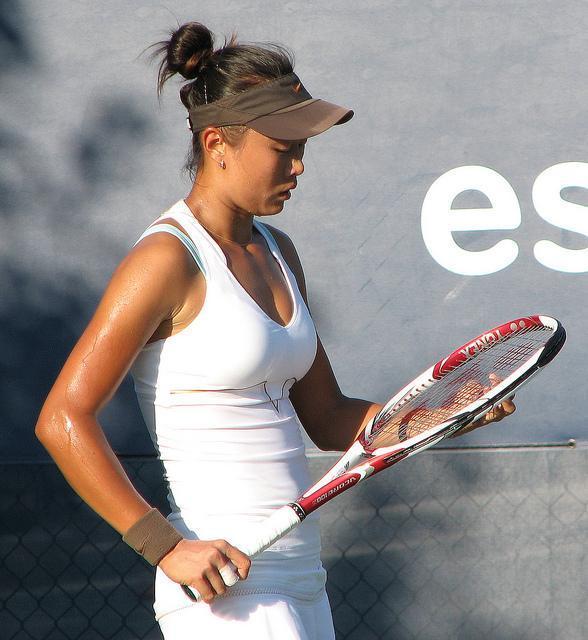How many kites are in the air?
Give a very brief answer. 0. 